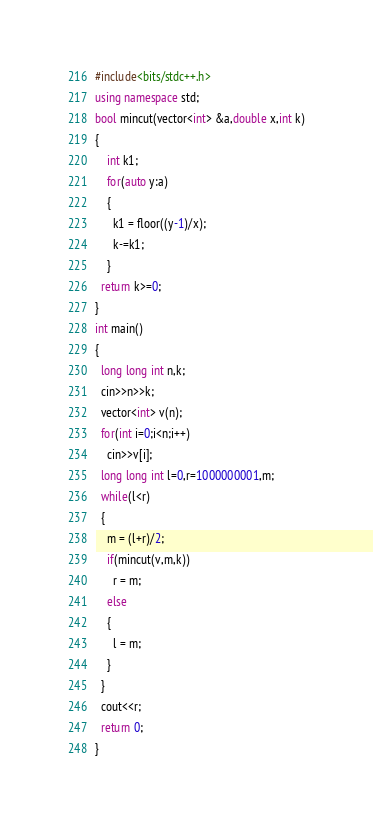Convert code to text. <code><loc_0><loc_0><loc_500><loc_500><_C++_>#include<bits/stdc++.h>
using namespace std;
bool mincut(vector<int> &a,double x,int k)
{
	int k1;
  	for(auto y:a)
    {
      k1 = floor((y-1)/x);
      k-=k1;
    }
  return k>=0;
}
int main()
{
  long long int n,k;
  cin>>n>>k;
  vector<int> v(n);
  for(int i=0;i<n;i++)
    cin>>v[i];
  long long int l=0,r=1000000001,m;
  while(l<r)
  {
    m = (l+r)/2;
    if(mincut(v,m,k))
      r = m;
    else
    {
      l = m;
    }
  }
  cout<<r;
  return 0;
}</code> 